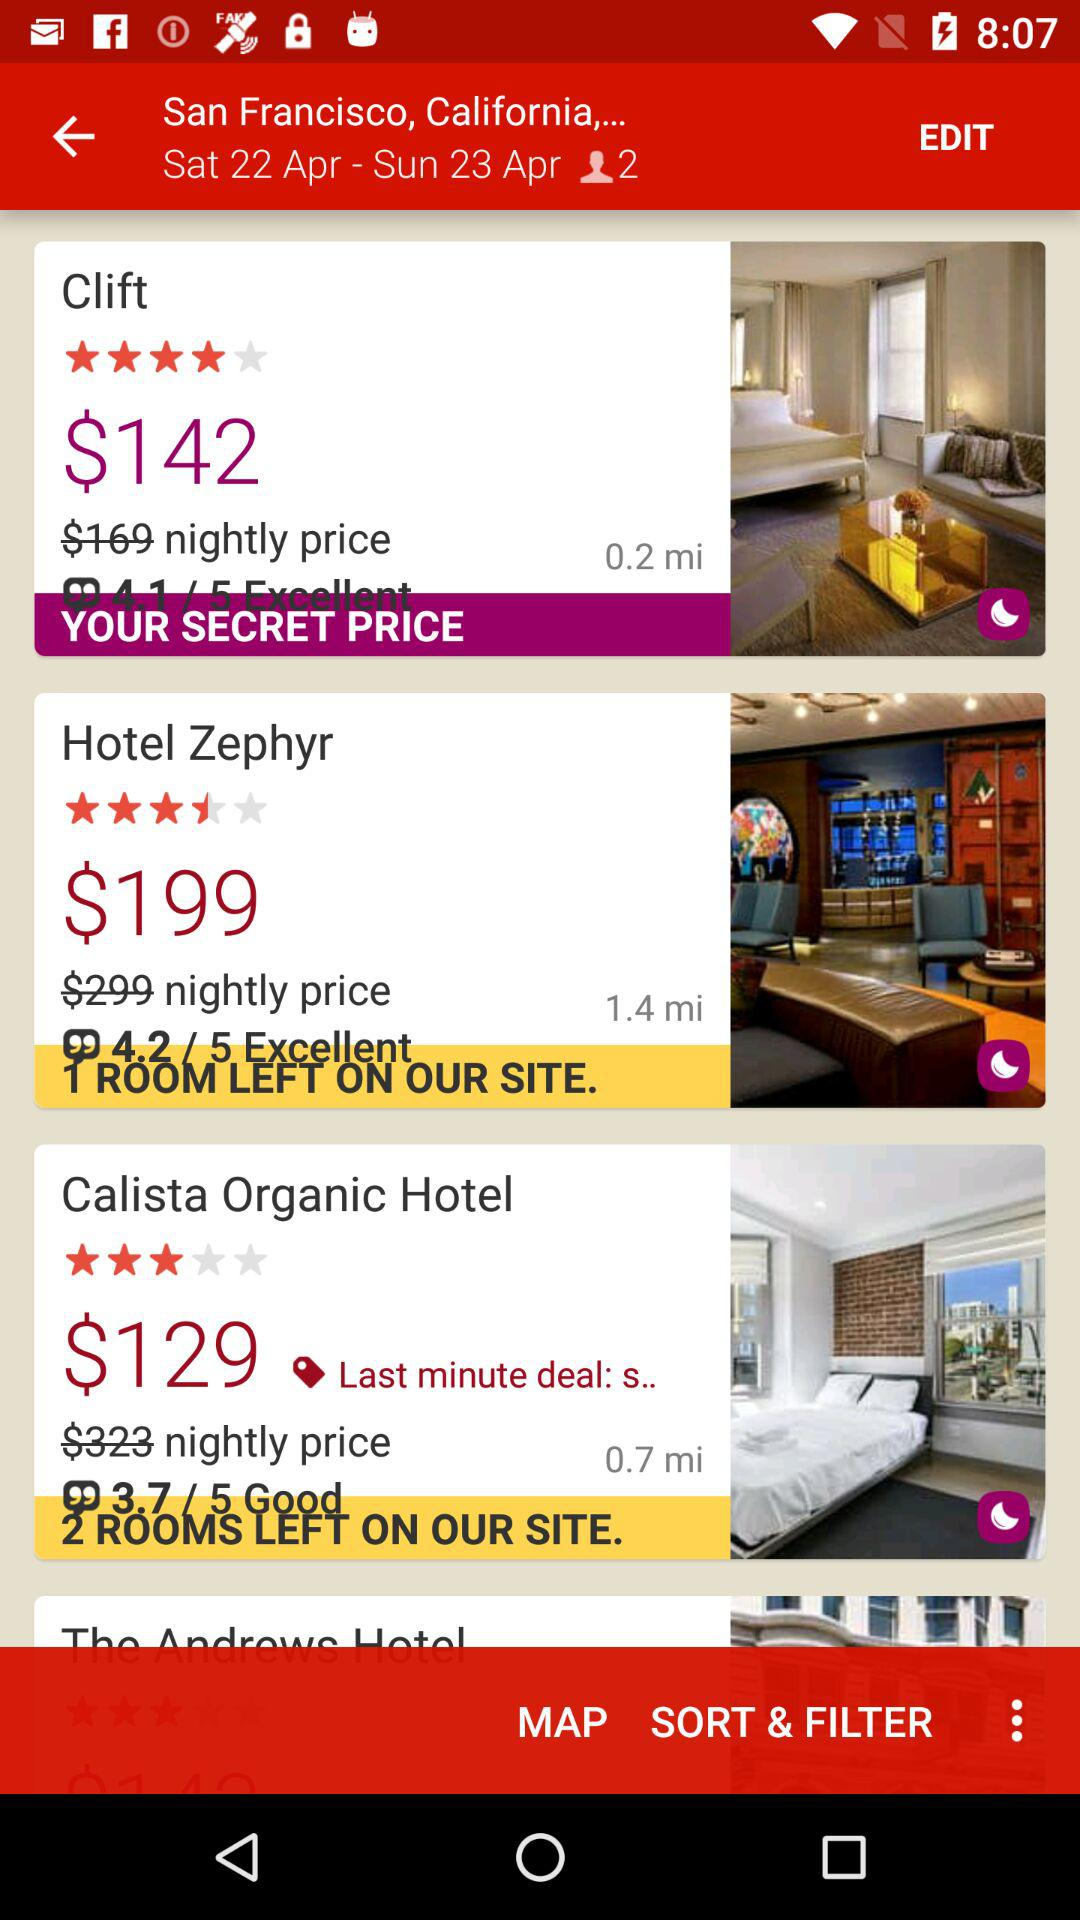How many rooms are left at the Hotel Zephyr? There is 1 room left. 